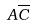<formula> <loc_0><loc_0><loc_500><loc_500>A \overline { C }</formula> 